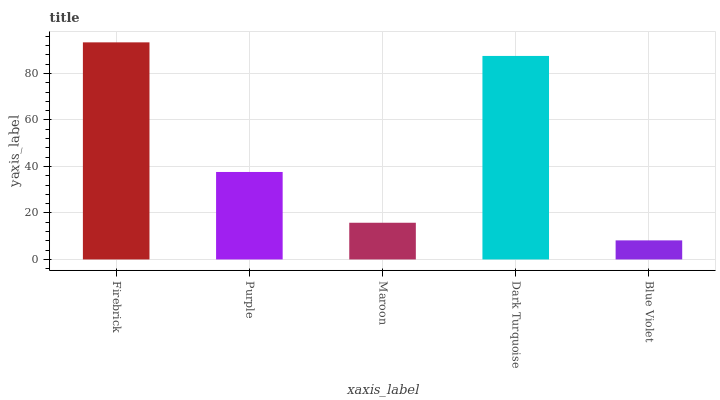Is Blue Violet the minimum?
Answer yes or no. Yes. Is Firebrick the maximum?
Answer yes or no. Yes. Is Purple the minimum?
Answer yes or no. No. Is Purple the maximum?
Answer yes or no. No. Is Firebrick greater than Purple?
Answer yes or no. Yes. Is Purple less than Firebrick?
Answer yes or no. Yes. Is Purple greater than Firebrick?
Answer yes or no. No. Is Firebrick less than Purple?
Answer yes or no. No. Is Purple the high median?
Answer yes or no. Yes. Is Purple the low median?
Answer yes or no. Yes. Is Firebrick the high median?
Answer yes or no. No. Is Firebrick the low median?
Answer yes or no. No. 